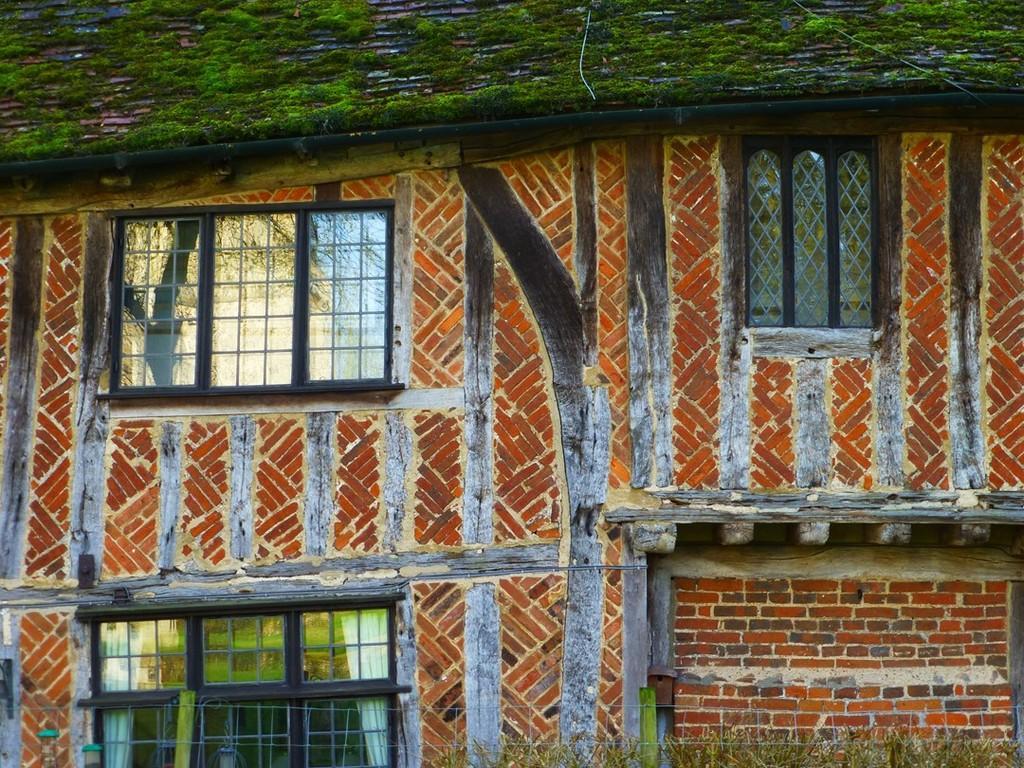Could you give a brief overview of what you see in this image? This picture shows a building and we see windows and some grass on the roof. 